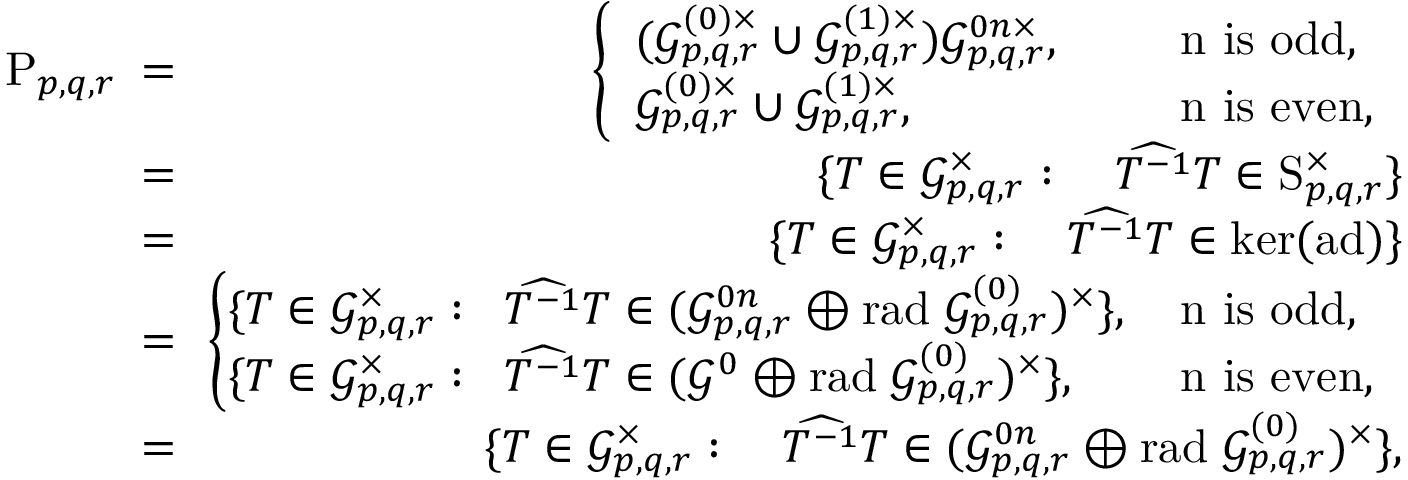<formula> <loc_0><loc_0><loc_500><loc_500>\begin{array} { r l r } { \, P _ { p , q , r } \, } & { = } & { \, \left \{ \begin{array} { l l l } { ( \mathcal { G } _ { p , q , r } ^ { ( 0 ) \times } \cup \mathcal { G } _ { p , q , r } ^ { ( 1 ) \times } ) \mathcal { G } _ { p , q , r } ^ { 0 n \times } , } & { \, } & { n i s o d d , } \\ { \mathcal { G } _ { p , q , r } ^ { ( 0 ) \times } \cup \mathcal { G } _ { p , q , r } ^ { ( 1 ) \times } , } & { \, } & { n i s e v e n , } \end{array} } \\ { \, } & { = } & { \, \{ T \in \mathcal { G } _ { p , q , r } ^ { \times } \colon \quad \widehat { T ^ { - 1 } } T \in S _ { p , q , r } ^ { \times } \} } \\ { \, } & { = } & { \, \{ T \in \mathcal { G } _ { p , q , r } ^ { \times } \colon \quad \widehat { T ^ { - 1 } } T \in k e r ( a d ) \} } \\ { \, } & { = } & { \, \left \{ \begin{array} { l l l } { \, \{ T \in \mathcal { G } _ { p , q , r } ^ { \times } \colon \, \widehat { T ^ { - 1 } } T \in ( \mathcal { G } _ { p , q , r } ^ { 0 n } \oplus r a d \, \mathcal { G } _ { p , q , r } ^ { ( 0 ) } ) ^ { \times } \} , \, } & & { n i s o d d , } \\ { \, \{ T \in \mathcal { G } _ { p , q , r } ^ { \times } \colon \, \widehat { T ^ { - 1 } } T \in ( \mathcal { G } ^ { 0 } \oplus r a d \, \mathcal { G } _ { p , q , r } ^ { ( 0 ) } ) ^ { \times } \} , \, } & & { n i s e v e n , } \end{array} } \\ { \, } & { = } & { \, \{ T \in \mathcal { G } _ { p , q , r } ^ { \times } \colon \quad \widehat { T ^ { - 1 } } T \in ( \mathcal { G } _ { p , q , r } ^ { 0 n } \oplus r a d \, \mathcal { G } _ { p , q , r } ^ { ( 0 ) } ) ^ { \times } \} , } \end{array}</formula> 